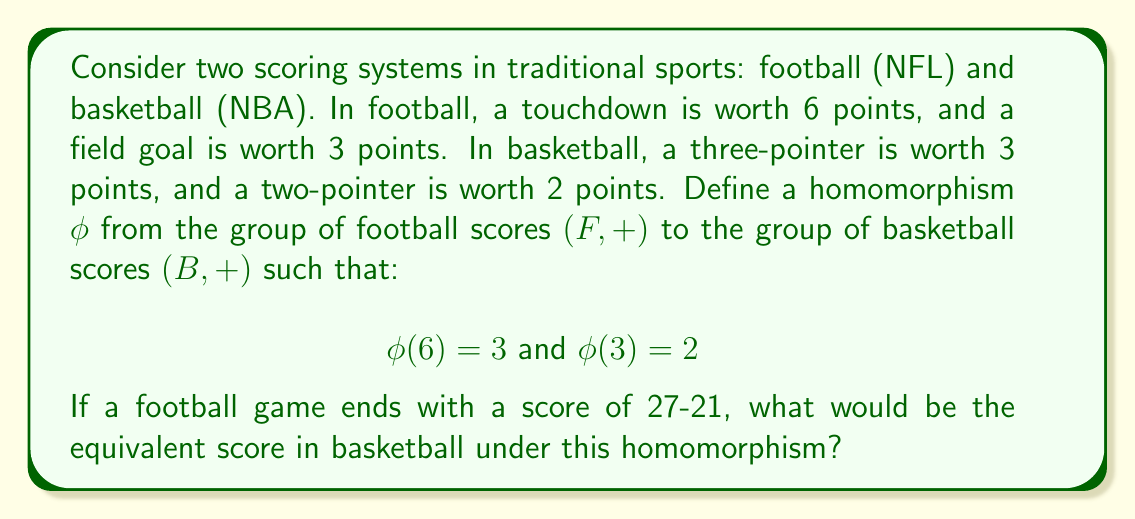Can you solve this math problem? To solve this problem, we need to understand the concept of homomorphism and how it applies to these scoring systems:

1) A homomorphism $\phi: F \to B$ is a function that preserves the group operation. In this case, the operation is addition for both groups.

2) We're given that $\phi(6) = 3$ and $\phi(3) = 2$. This means:
   - A touchdown (6 points) in football maps to a three-pointer in basketball.
   - A field goal (3 points) in football maps to a two-pointer in basketball.

3) Let's break down the football scores:
   - 27 = 6 + 6 + 6 + 3 + 3 + 3 (4 touchdowns + 3 field goals)
   - 21 = 6 + 6 + 6 + 3 (3 touchdowns + 1 field goal)

4) Now, let's apply the homomorphism:
   - $\phi(27) = \phi(6 + 6 + 6 + 3 + 3 + 3)$
   - Since $\phi$ is a homomorphism, $\phi(a + b) = \phi(a) + \phi(b)$
   - So, $\phi(27) = \phi(6) + \phi(6) + \phi(6) + \phi(3) + \phi(3) + \phi(3)$
   - $\phi(27) = 3 + 3 + 3 + 2 + 2 + 2 = 15$

5) Similarly for 21:
   - $\phi(21) = \phi(6 + 6 + 6 + 3) = \phi(6) + \phi(6) + \phi(6) + \phi(3)$
   - $\phi(21) = 3 + 3 + 3 + 2 = 11$

Therefore, under this homomorphism, the football score of 27-21 would be equivalent to a basketball score of 15-11.
Answer: 15-11 